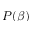<formula> <loc_0><loc_0><loc_500><loc_500>P ( \beta )</formula> 